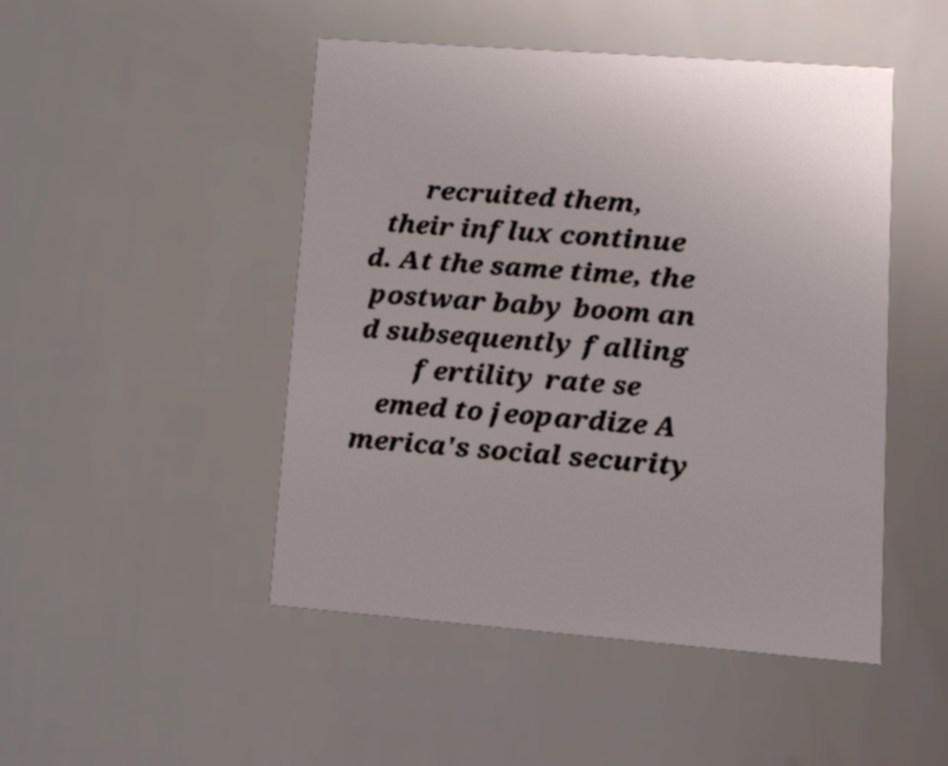Could you assist in decoding the text presented in this image and type it out clearly? recruited them, their influx continue d. At the same time, the postwar baby boom an d subsequently falling fertility rate se emed to jeopardize A merica's social security 